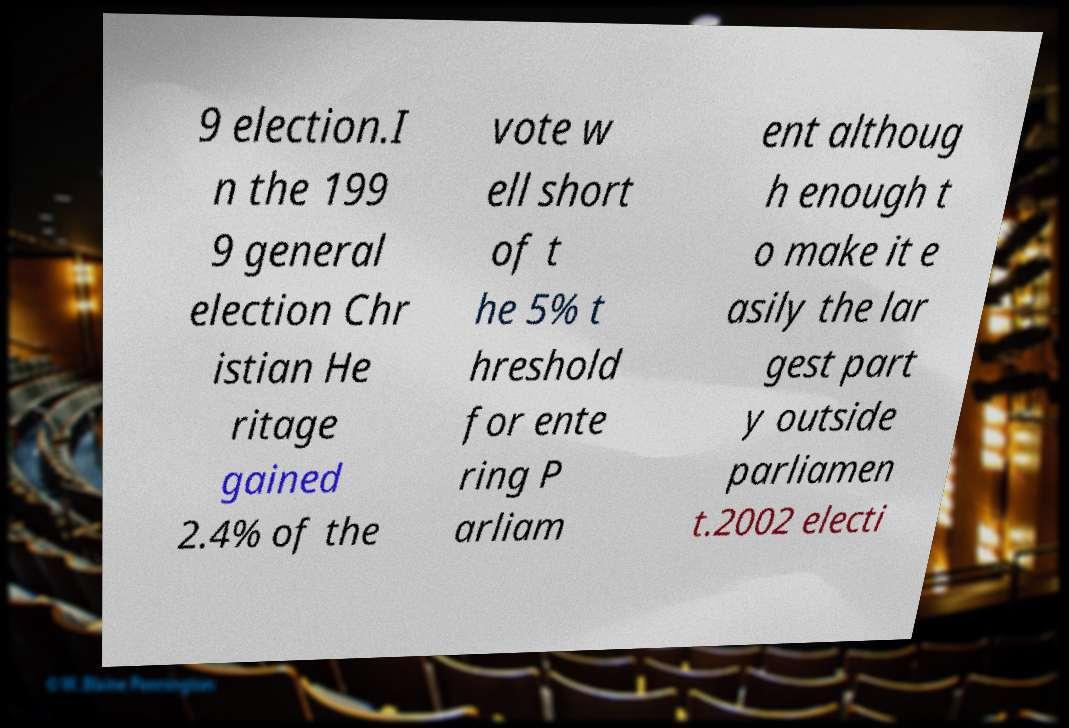Can you accurately transcribe the text from the provided image for me? 9 election.I n the 199 9 general election Chr istian He ritage gained 2.4% of the vote w ell short of t he 5% t hreshold for ente ring P arliam ent althoug h enough t o make it e asily the lar gest part y outside parliamen t.2002 electi 